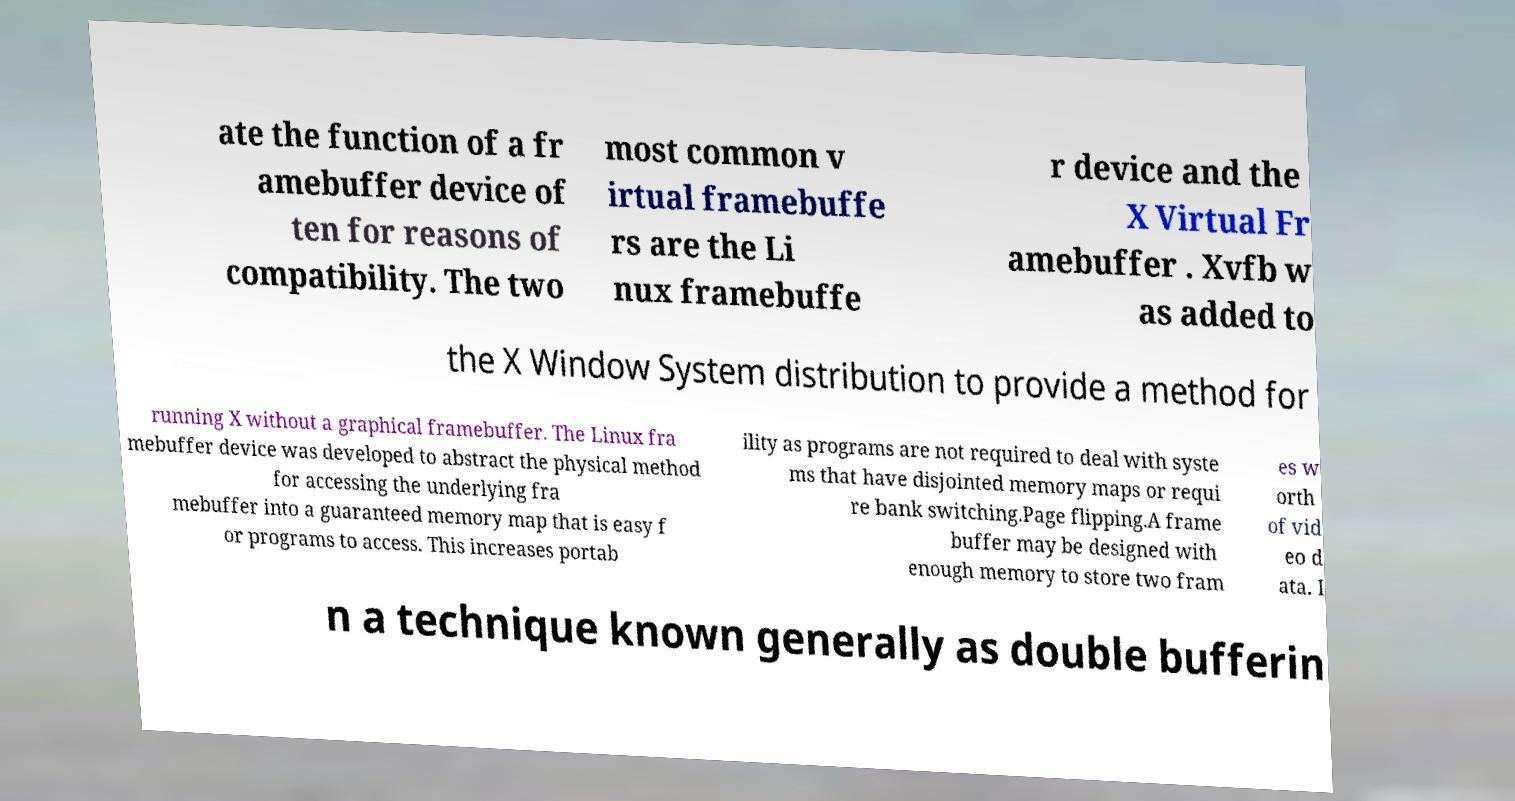There's text embedded in this image that I need extracted. Can you transcribe it verbatim? ate the function of a fr amebuffer device of ten for reasons of compatibility. The two most common v irtual framebuffe rs are the Li nux framebuffe r device and the X Virtual Fr amebuffer . Xvfb w as added to the X Window System distribution to provide a method for running X without a graphical framebuffer. The Linux fra mebuffer device was developed to abstract the physical method for accessing the underlying fra mebuffer into a guaranteed memory map that is easy f or programs to access. This increases portab ility as programs are not required to deal with syste ms that have disjointed memory maps or requi re bank switching.Page flipping.A frame buffer may be designed with enough memory to store two fram es w orth of vid eo d ata. I n a technique known generally as double bufferin 